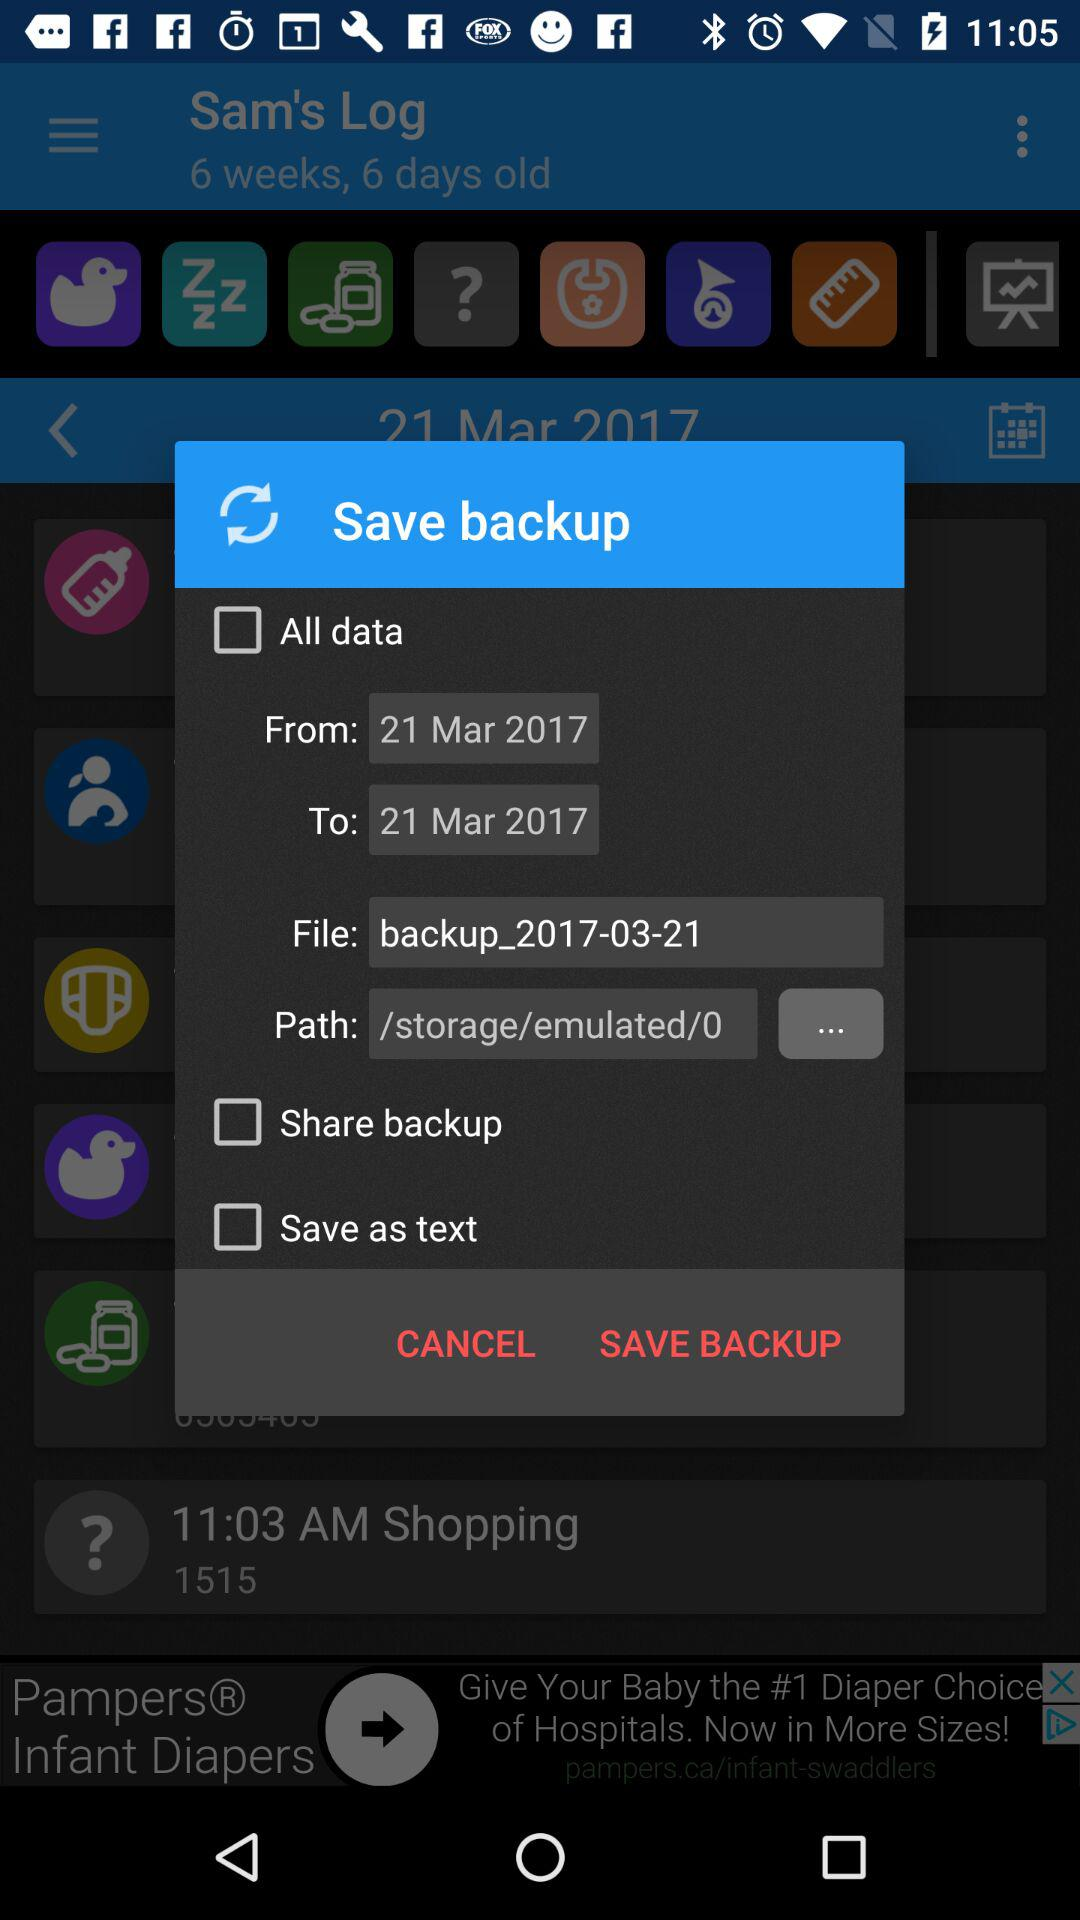Which date range is selected for backing up all data? The selected date range for backing up all data is from March 21, 2017 to March 21, 2017. 